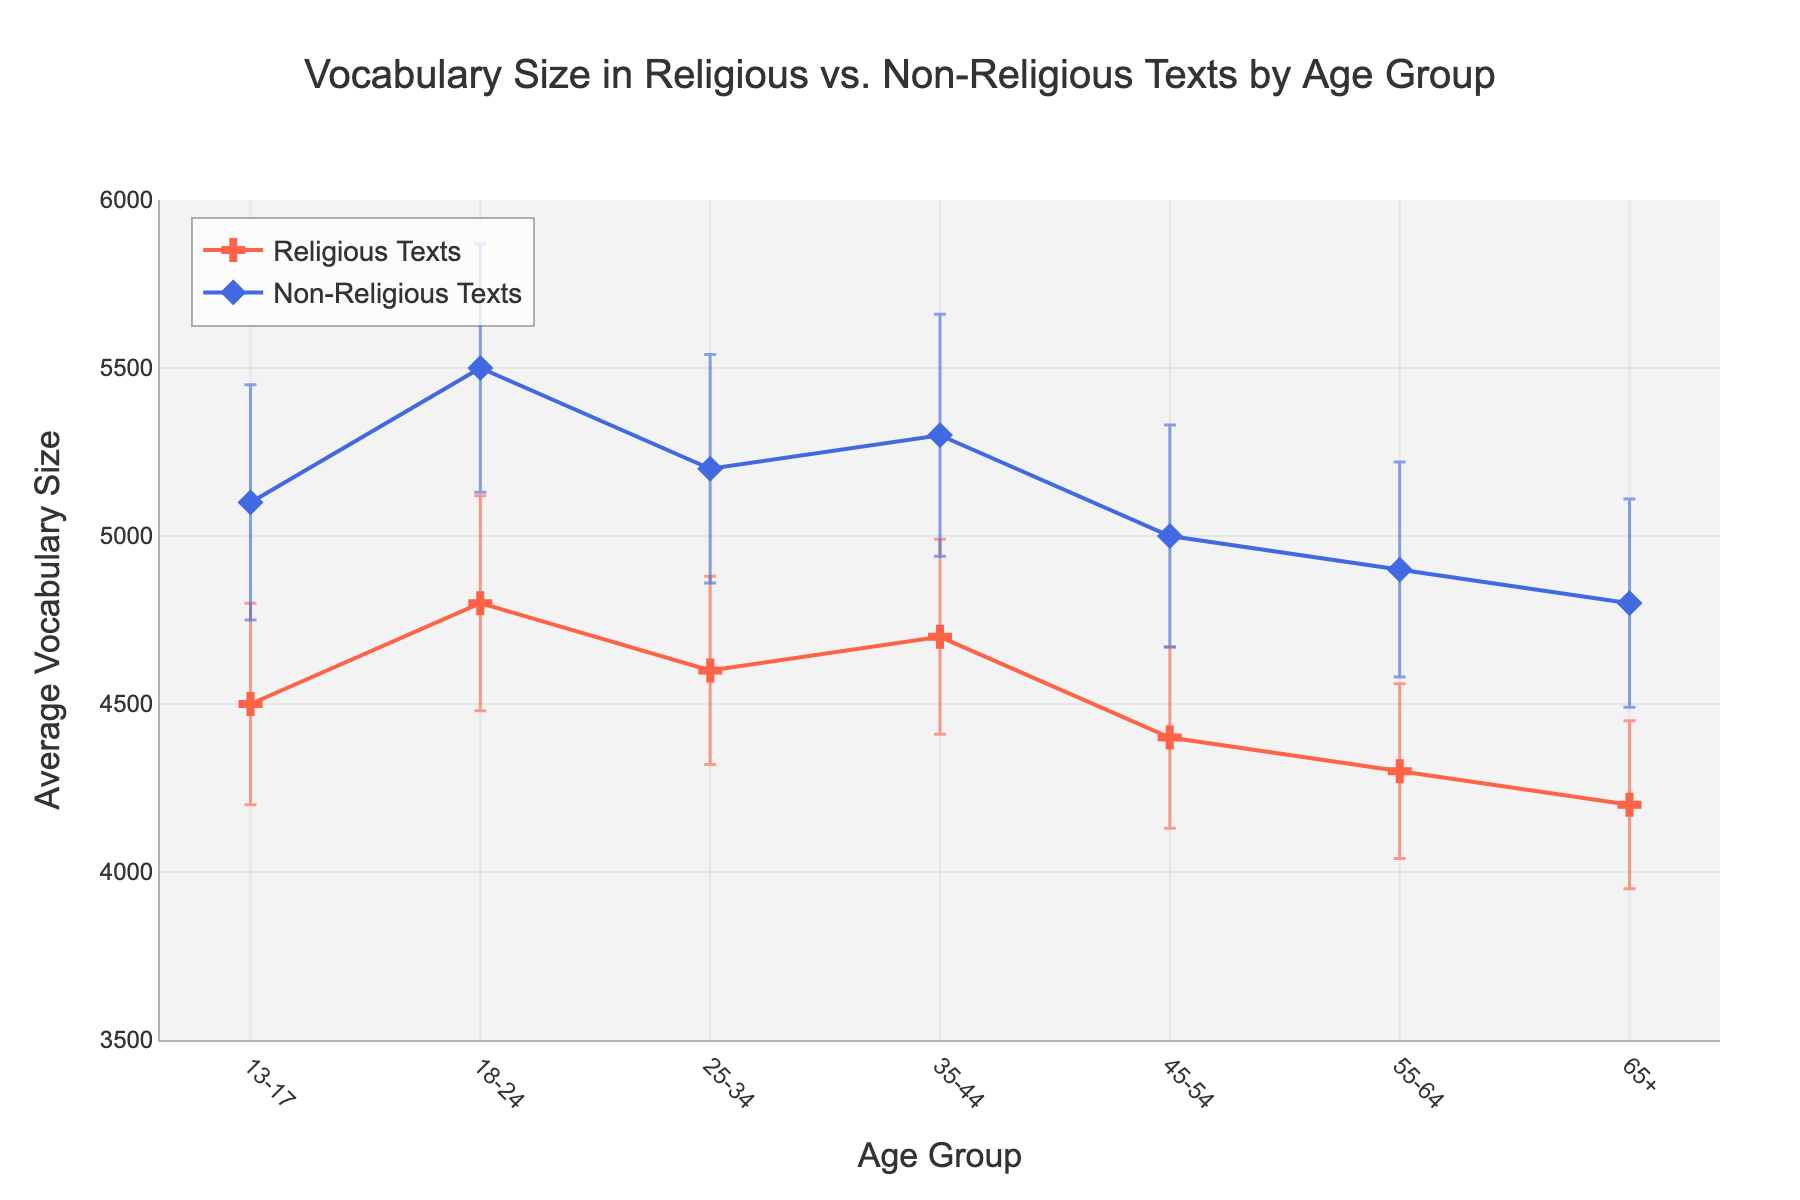What's the title of the plot? The title of the plot is located at the top of the figure. It clearly states the purpose of the plot.
Answer: Vocabulary Size in Religious vs. Non-Religious Texts by Age Group What does the y-axis represent? The y-axis represents the average vocabulary size, which helps to understand the vocabulary use in different texts across age groups.
Answer: Average Vocabulary Size Which text type has a higher vocabulary size for the age group 18-24? By comparing the average vocabulary size of both text types for the specified age group, it is visible that Non-Religious Texts have a higher average vocabulary size.
Answer: Non-Religious Texts What is the approximate vocabulary size difference between Religious Texts and Non-Religious Texts for the age group 65+? Subtract the vocabulary size of Religious Texts from that of Non-Religious Texts for the age group 65+: 4800 - 4200.
Answer: 600 Which age group shows the highest average vocabulary size in Non-Religious Texts? By observing the y-values for Non-Religious Texts, the highest average vocabulary size is at the age group 18-24.
Answer: 18-24 Does the vocabulary size in Religious Texts show a consistent trend across age groups? To answer this, we observe the line corresponding to Religious Texts and notice whether it increases, decreases, or remains stable across different age groups.
Answer: No, it generally decreases with age What is the maximum error (standard deviation) shown for Religious Texts? By looking at the error bars for Religious Texts, the tallest error bar indicates the largest value, which is for the age group 18-24.
Answer: 320 Comparing the standard deviations, which text type seems to have larger uncertainty overall? Observing both the height and frequency of the error bars for each text type, Non-Religious Texts display larger and more frequent error bars, indicating greater uncertainty.
Answer: Non-Religious Texts What is the vocabulary size range for the age group 45-54 in Non-Religious Texts? The range can be calculated by adding and subtracting the standard deviation from the average for this age group: 5000 ± 330.
Answer: 4670 to 5330 